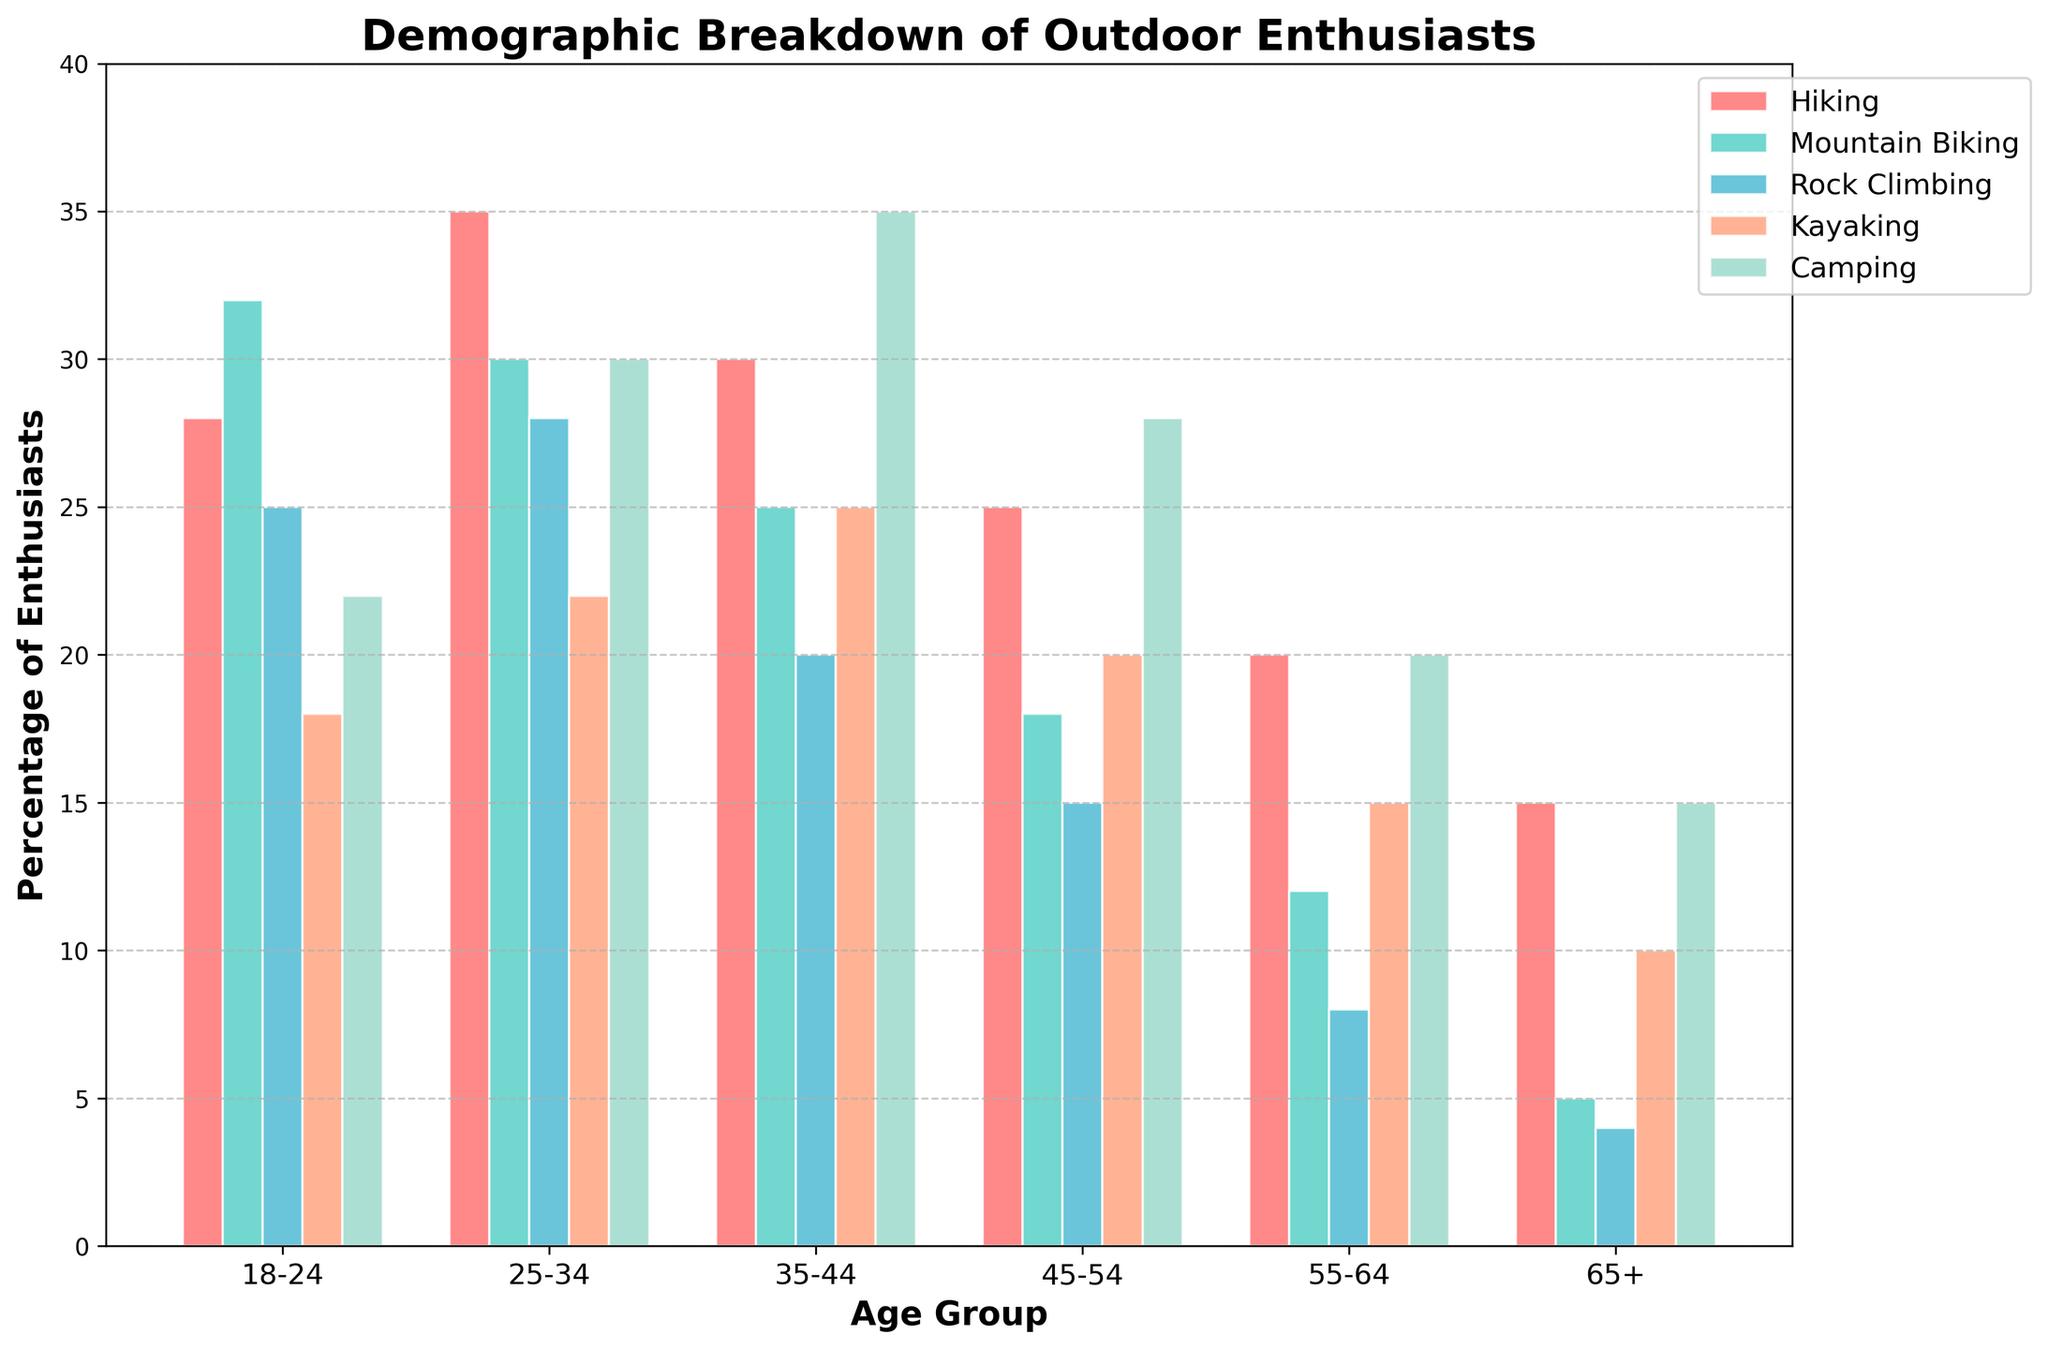How many more outdoor enthusiasts aged 25-34 prefer hiking compared to those aged 45-54? First, identify the number of hiking enthusiasts in the age group 25-34, which is 35. Next, identify the number in the age group 45-54, which is 25. Subtract the smaller value from the larger value: 35 - 25 = 10.
Answer: 10 Which age group has the highest number of camping enthusiasts? Scan the 'Camping' column for the highest value. The age groups and their camping values are: 18-24: 22, 25-34: 30, 35-44: 35, 45-54: 28, 55-64: 20, 65+: 15. The highest value is 35 in the 35-44 age group.
Answer: 35-44 How does the number of kayaking enthusiasts in the age group 18-24 compare to those in the age group 55-64? For the age group 18-24, the number of kayaking enthusiasts is 18. For the age group 55-64, it is 15. Compare the two numbers: 18 is greater than 15 by 3.
Answer: 18 is greater by 3 What is the average number of mountain biking enthusiasts across all age groups? Add up the numbers in the 'Mountain Biking' column: 32 + 30 + 25 + 18 + 12 + 5 = 122. Divide the sum by the number of age groups, which is 6: 122 / 6 ≈ 20.33.
Answer: Approximately 20.33 Which activity has the widest variation in numbers between the age groups? Compare the range (max value - min value) for each activity. The ranges are: Hiking: 35-15 = 20, Mountain Biking: 32-5 = 27, Rock Climbing: 28-4 = 24, Kayaking: 25-10 = 15, Camping: 35-15 = 20. Mountain Biking has the widest variation with a range of 27.
Answer: Mountain Biking Which activity has the least number of enthusiasts aged 65+? Look at the '65+' row and find the minimum value. The values are: Hiking: 15, Mountain Biking: 5, Rock Climbing: 4, Kayaking: 10, Camping: 15. The least number is 4 for Rock Climbing.
Answer: Rock Climbing How does the total number of rock climbing enthusiasts below the age of 35 compare to those aged 35 and above? Sum the numbers of rock climbing enthusiasts below 35: 25 (18-24) + 28 (25-34) = 53. Sum the numbers for age 35 and above: 20 (35-44) + 15 (45-54) + 8 (55-64) + 4 (65+) = 47. Compare the two totals: 53 > 47.
Answer: 53 is greater by 6 